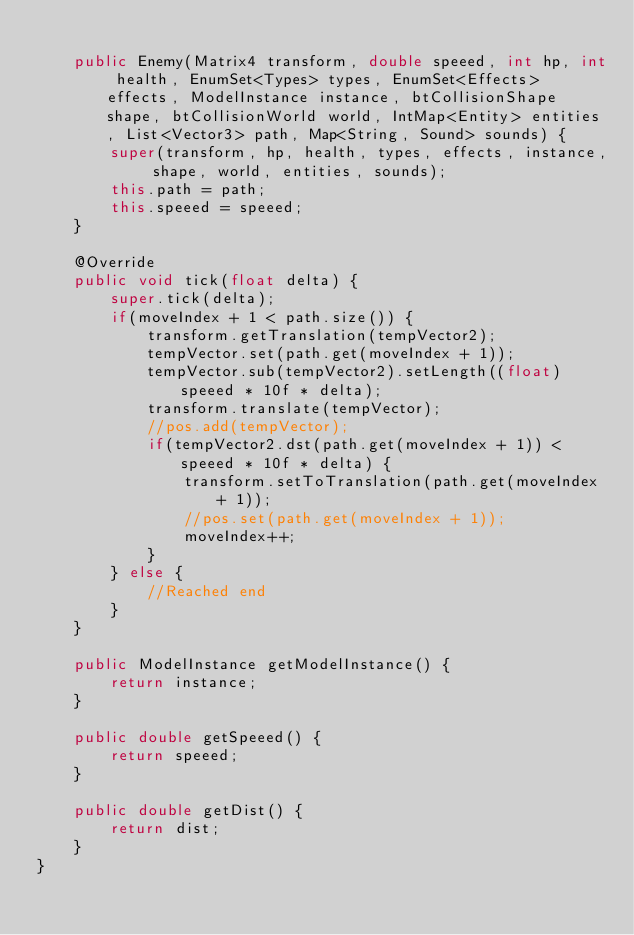Convert code to text. <code><loc_0><loc_0><loc_500><loc_500><_Java_>
    public Enemy(Matrix4 transform, double speeed, int hp, int health, EnumSet<Types> types, EnumSet<Effects> effects, ModelInstance instance, btCollisionShape shape, btCollisionWorld world, IntMap<Entity> entities, List<Vector3> path, Map<String, Sound> sounds) {
        super(transform, hp, health, types, effects, instance, shape, world, entities, sounds);
        this.path = path;
        this.speeed = speeed;
    }

    @Override
    public void tick(float delta) {
        super.tick(delta);
        if(moveIndex + 1 < path.size()) {
            transform.getTranslation(tempVector2);
            tempVector.set(path.get(moveIndex + 1));
            tempVector.sub(tempVector2).setLength((float) speeed * 10f * delta);
            transform.translate(tempVector);
            //pos.add(tempVector);
            if(tempVector2.dst(path.get(moveIndex + 1)) < speeed * 10f * delta) {
                transform.setToTranslation(path.get(moveIndex + 1));
                //pos.set(path.get(moveIndex + 1));
                moveIndex++;
            }
        } else {
            //Reached end
        }
    }

    public ModelInstance getModelInstance() {
        return instance;
    }
    
    public double getSpeeed() {
        return speeed;
    }

    public double getDist() {
        return dist;
    }
}
</code> 